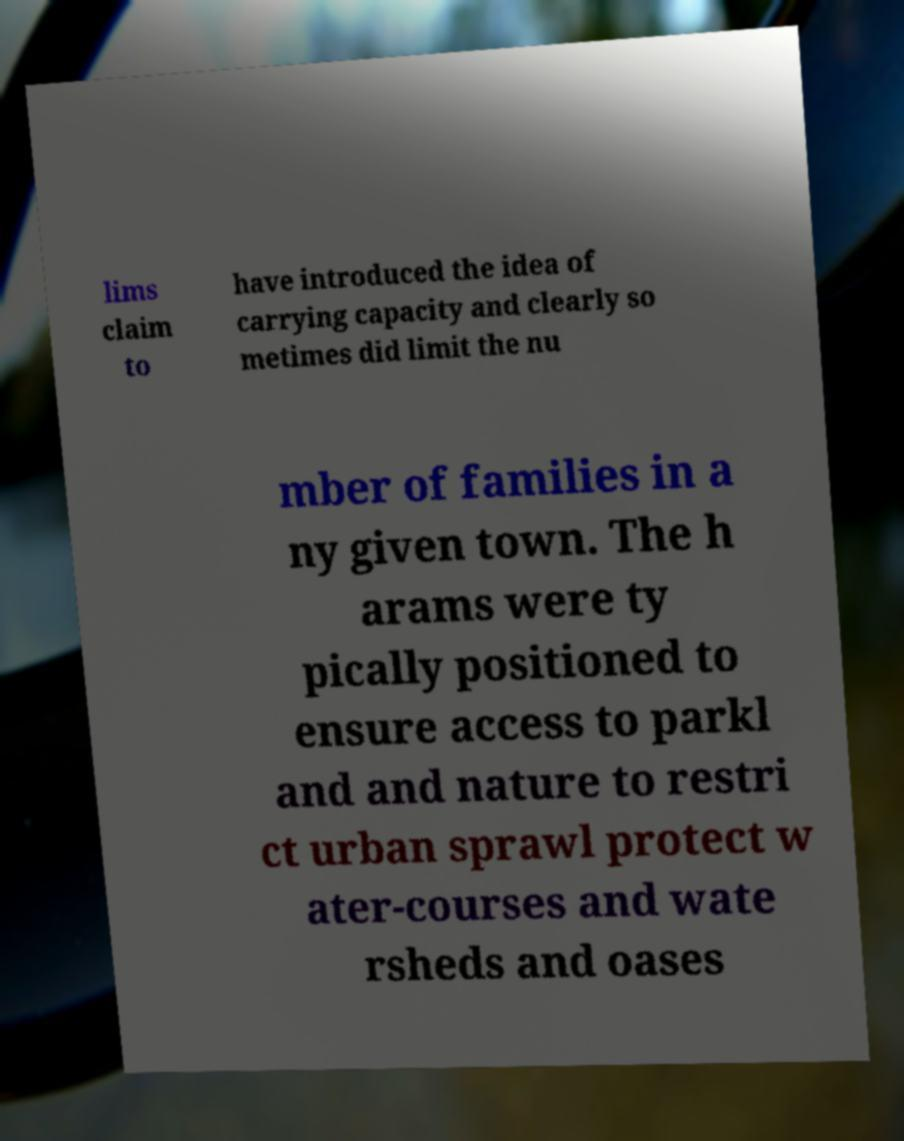For documentation purposes, I need the text within this image transcribed. Could you provide that? lims claim to have introduced the idea of carrying capacity and clearly so metimes did limit the nu mber of families in a ny given town. The h arams were ty pically positioned to ensure access to parkl and and nature to restri ct urban sprawl protect w ater-courses and wate rsheds and oases 